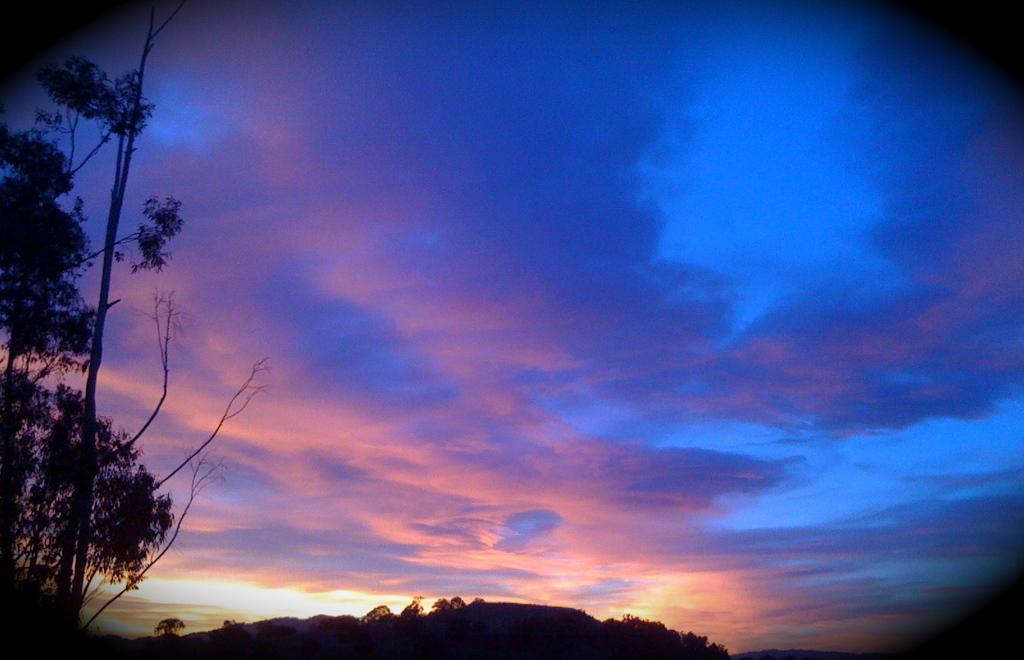How would you summarize this image in a sentence or two? In this picture we can see trees and in the background we can see the sky with clouds. 